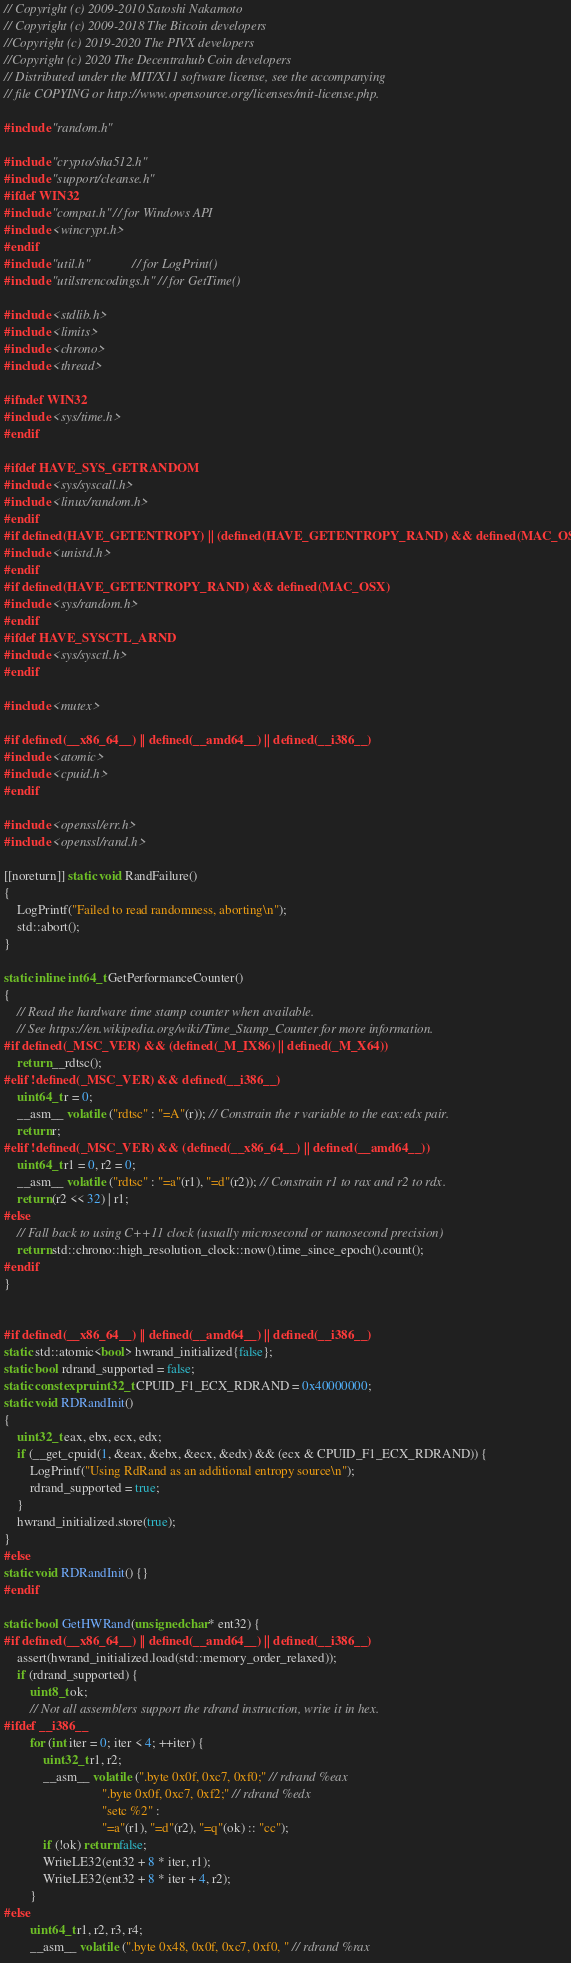Convert code to text. <code><loc_0><loc_0><loc_500><loc_500><_C++_>// Copyright (c) 2009-2010 Satoshi Nakamoto
// Copyright (c) 2009-2018 The Bitcoin developers
//Copyright (c) 2019-2020 The PIVX developers
//Copyright (c) 2020 The Decentrahub Coin developers
// Distributed under the MIT/X11 software license, see the accompanying
// file COPYING or http://www.opensource.org/licenses/mit-license.php.

#include "random.h"

#include "crypto/sha512.h"
#include "support/cleanse.h"
#ifdef WIN32
#include "compat.h" // for Windows API
#include <wincrypt.h>
#endif
#include "util.h"             // for LogPrint()
#include "utilstrencodings.h" // for GetTime()

#include <stdlib.h>
#include <limits>
#include <chrono>
#include <thread>

#ifndef WIN32
#include <sys/time.h>
#endif

#ifdef HAVE_SYS_GETRANDOM
#include <sys/syscall.h>
#include <linux/random.h>
#endif
#if defined(HAVE_GETENTROPY) || (defined(HAVE_GETENTROPY_RAND) && defined(MAC_OSX))
#include <unistd.h>
#endif
#if defined(HAVE_GETENTROPY_RAND) && defined(MAC_OSX)
#include <sys/random.h>
#endif
#ifdef HAVE_SYSCTL_ARND
#include <sys/sysctl.h>
#endif

#include <mutex>

#if defined(__x86_64__) || defined(__amd64__) || defined(__i386__)
#include <atomic>
#include <cpuid.h>
#endif

#include <openssl/err.h>
#include <openssl/rand.h>

[[noreturn]] static void RandFailure()
{
    LogPrintf("Failed to read randomness, aborting\n");
    std::abort();
}

static inline int64_t GetPerformanceCounter()
{
    // Read the hardware time stamp counter when available.
    // See https://en.wikipedia.org/wiki/Time_Stamp_Counter for more information.
#if defined(_MSC_VER) && (defined(_M_IX86) || defined(_M_X64))
    return __rdtsc();
#elif !defined(_MSC_VER) && defined(__i386__)
    uint64_t r = 0;
    __asm__ volatile ("rdtsc" : "=A"(r)); // Constrain the r variable to the eax:edx pair.
    return r;
#elif !defined(_MSC_VER) && (defined(__x86_64__) || defined(__amd64__))
    uint64_t r1 = 0, r2 = 0;
    __asm__ volatile ("rdtsc" : "=a"(r1), "=d"(r2)); // Constrain r1 to rax and r2 to rdx.
    return (r2 << 32) | r1;
#else
    // Fall back to using C++11 clock (usually microsecond or nanosecond precision)
    return std::chrono::high_resolution_clock::now().time_since_epoch().count();
#endif
}


#if defined(__x86_64__) || defined(__amd64__) || defined(__i386__)
static std::atomic<bool> hwrand_initialized{false};
static bool rdrand_supported = false;
static constexpr uint32_t CPUID_F1_ECX_RDRAND = 0x40000000;
static void RDRandInit()
{
    uint32_t eax, ebx, ecx, edx;
    if (__get_cpuid(1, &eax, &ebx, &ecx, &edx) && (ecx & CPUID_F1_ECX_RDRAND)) {
        LogPrintf("Using RdRand as an additional entropy source\n");
        rdrand_supported = true;
    }
    hwrand_initialized.store(true);
}
#else
static void RDRandInit() {}
#endif

static bool GetHWRand(unsigned char* ent32) {
#if defined(__x86_64__) || defined(__amd64__) || defined(__i386__)
    assert(hwrand_initialized.load(std::memory_order_relaxed));
    if (rdrand_supported) {
        uint8_t ok;
        // Not all assemblers support the rdrand instruction, write it in hex.
#ifdef __i386__
        for (int iter = 0; iter < 4; ++iter) {
            uint32_t r1, r2;
            __asm__ volatile (".byte 0x0f, 0xc7, 0xf0;" // rdrand %eax
                              ".byte 0x0f, 0xc7, 0xf2;" // rdrand %edx
                              "setc %2" :
                              "=a"(r1), "=d"(r2), "=q"(ok) :: "cc");
            if (!ok) return false;
            WriteLE32(ent32 + 8 * iter, r1);
            WriteLE32(ent32 + 8 * iter + 4, r2);
        }
#else
        uint64_t r1, r2, r3, r4;
        __asm__ volatile (".byte 0x48, 0x0f, 0xc7, 0xf0, " // rdrand %rax</code> 